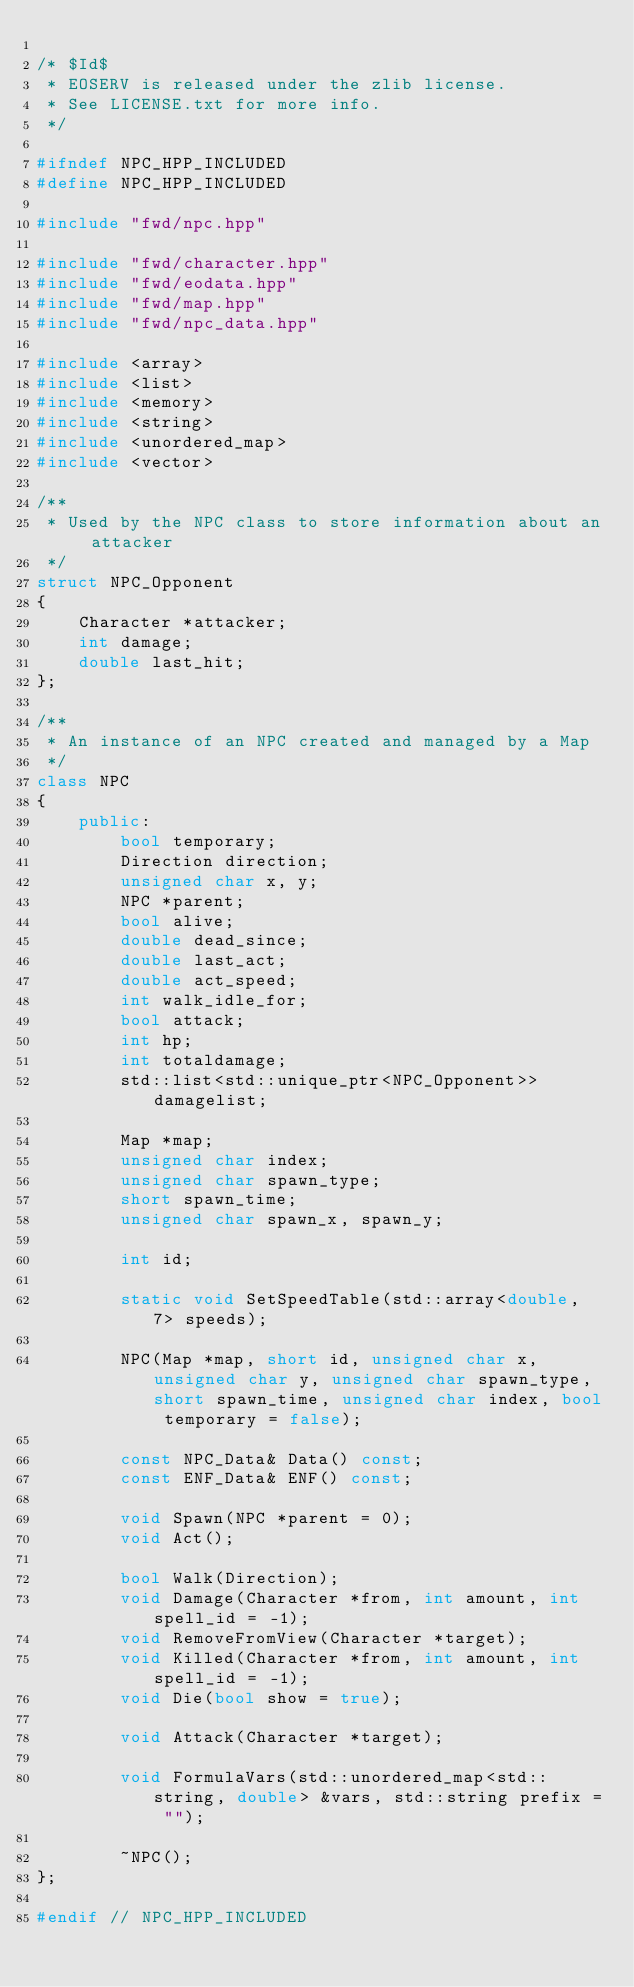Convert code to text. <code><loc_0><loc_0><loc_500><loc_500><_C++_>
/* $Id$
 * EOSERV is released under the zlib license.
 * See LICENSE.txt for more info.
 */

#ifndef NPC_HPP_INCLUDED
#define NPC_HPP_INCLUDED

#include "fwd/npc.hpp"

#include "fwd/character.hpp"
#include "fwd/eodata.hpp"
#include "fwd/map.hpp"
#include "fwd/npc_data.hpp"

#include <array>
#include <list>
#include <memory>
#include <string>
#include <unordered_map>
#include <vector>

/**
 * Used by the NPC class to store information about an attacker
 */
struct NPC_Opponent
{
	Character *attacker;
	int damage;
	double last_hit;
};

/**
 * An instance of an NPC created and managed by a Map
 */
class NPC
{
	public:
		bool temporary;
		Direction direction;
		unsigned char x, y;
		NPC *parent;
		bool alive;
		double dead_since;
		double last_act;
		double act_speed;
		int walk_idle_for;
		bool attack;
		int hp;
		int totaldamage;
		std::list<std::unique_ptr<NPC_Opponent>> damagelist;

		Map *map;
		unsigned char index;
		unsigned char spawn_type;
		short spawn_time;
		unsigned char spawn_x, spawn_y;

		int id;

		static void SetSpeedTable(std::array<double, 7> speeds);

		NPC(Map *map, short id, unsigned char x, unsigned char y, unsigned char spawn_type, short spawn_time, unsigned char index, bool temporary = false);

		const NPC_Data& Data() const;
		const ENF_Data& ENF() const;

		void Spawn(NPC *parent = 0);
		void Act();

		bool Walk(Direction);
		void Damage(Character *from, int amount, int spell_id = -1);
		void RemoveFromView(Character *target);
		void Killed(Character *from, int amount, int spell_id = -1);
		void Die(bool show = true);

		void Attack(Character *target);

		void FormulaVars(std::unordered_map<std::string, double> &vars, std::string prefix = "");

		~NPC();
};

#endif // NPC_HPP_INCLUDED
</code> 